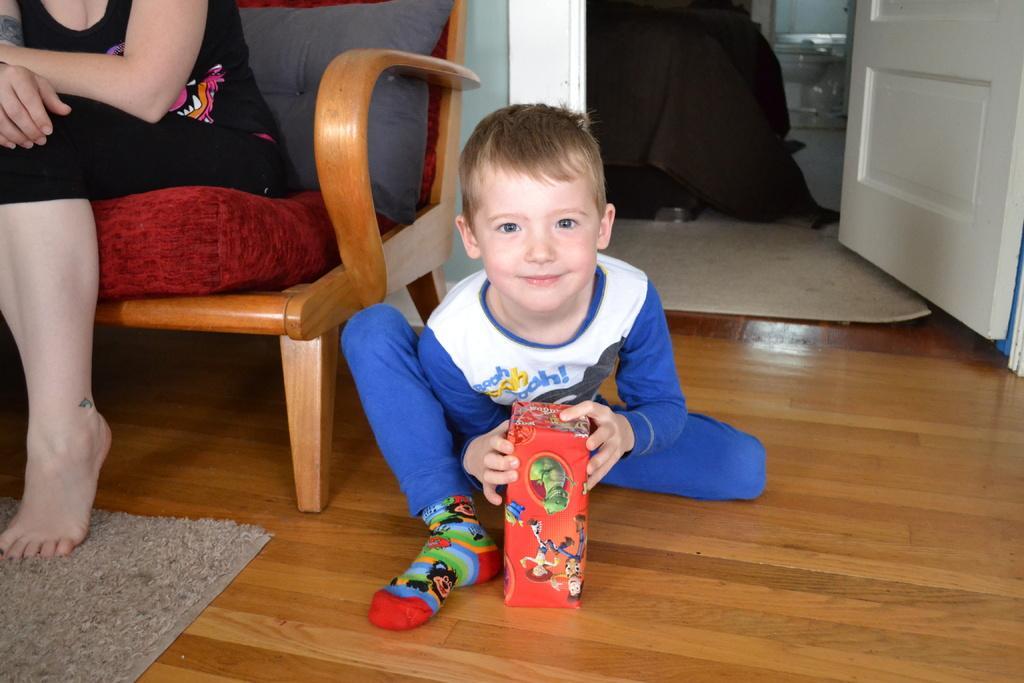In one or two sentences, can you explain what this image depicts? This picture shows a boy seated on the floor and holding a box in his hand we see a woman seated on the chair and we see a door and a carpet and we see a floor mat 